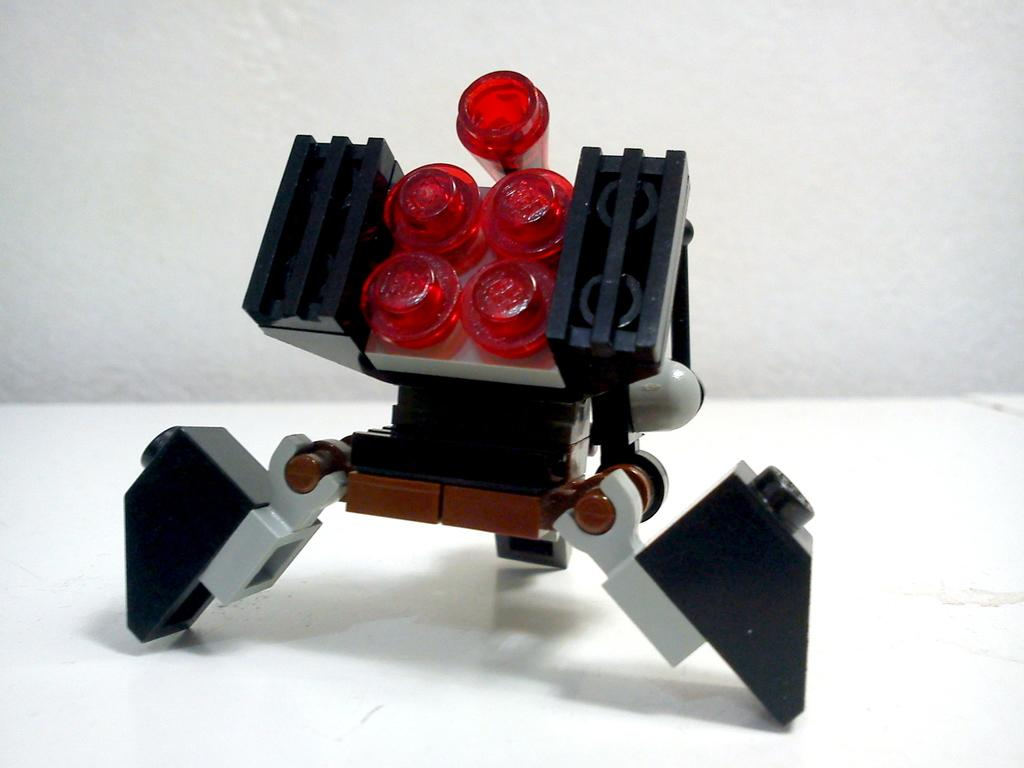What object can be seen in the image? There is a toy in the image. What colors are present on the toy? The toy has a black, white, and red color. What color is visible in the background of the image? There is white color visible in the background of the image. Are there any plants growing in the image? There are no plants visible in the image. Can you see a sail in the image? There is no sail present in the image. 